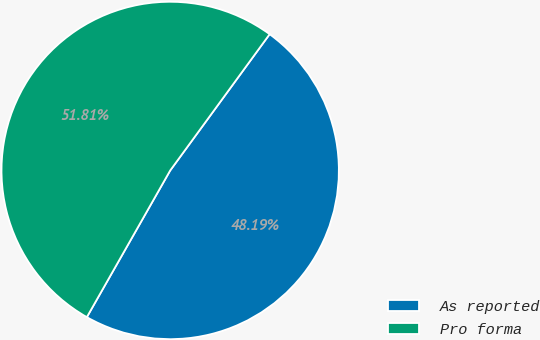Convert chart to OTSL. <chart><loc_0><loc_0><loc_500><loc_500><pie_chart><fcel>As reported<fcel>Pro forma<nl><fcel>48.19%<fcel>51.81%<nl></chart> 